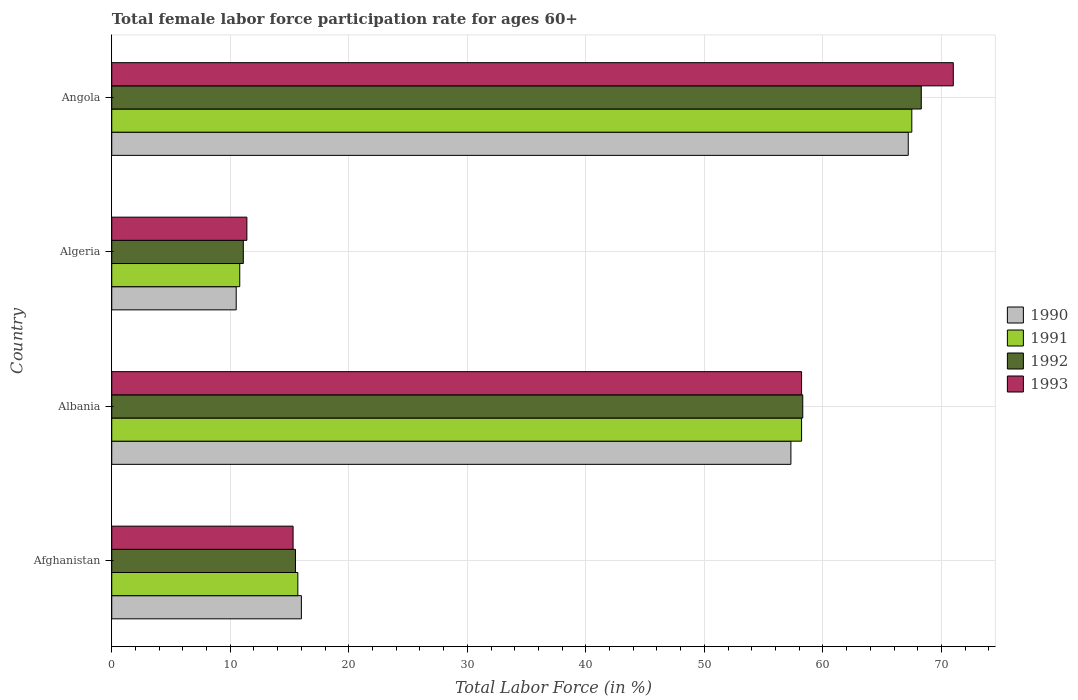How many groups of bars are there?
Provide a short and direct response. 4. Are the number of bars per tick equal to the number of legend labels?
Your answer should be compact. Yes. Are the number of bars on each tick of the Y-axis equal?
Offer a terse response. Yes. How many bars are there on the 2nd tick from the top?
Ensure brevity in your answer.  4. How many bars are there on the 2nd tick from the bottom?
Your response must be concise. 4. What is the label of the 2nd group of bars from the top?
Offer a very short reply. Algeria. What is the female labor force participation rate in 1992 in Angola?
Offer a terse response. 68.3. Across all countries, what is the maximum female labor force participation rate in 1992?
Your response must be concise. 68.3. Across all countries, what is the minimum female labor force participation rate in 1993?
Ensure brevity in your answer.  11.4. In which country was the female labor force participation rate in 1990 maximum?
Provide a succinct answer. Angola. In which country was the female labor force participation rate in 1990 minimum?
Make the answer very short. Algeria. What is the total female labor force participation rate in 1991 in the graph?
Your response must be concise. 152.2. What is the difference between the female labor force participation rate in 1990 in Algeria and that in Angola?
Your answer should be compact. -56.7. What is the difference between the female labor force participation rate in 1990 in Albania and the female labor force participation rate in 1991 in Algeria?
Make the answer very short. 46.5. What is the average female labor force participation rate in 1992 per country?
Your answer should be compact. 38.3. What is the difference between the female labor force participation rate in 1990 and female labor force participation rate in 1993 in Albania?
Keep it short and to the point. -0.9. In how many countries, is the female labor force participation rate in 1991 greater than 6 %?
Your answer should be compact. 4. What is the ratio of the female labor force participation rate in 1991 in Afghanistan to that in Algeria?
Your answer should be very brief. 1.45. Is the difference between the female labor force participation rate in 1990 in Albania and Algeria greater than the difference between the female labor force participation rate in 1993 in Albania and Algeria?
Provide a succinct answer. No. What is the difference between the highest and the second highest female labor force participation rate in 1991?
Ensure brevity in your answer.  9.3. What is the difference between the highest and the lowest female labor force participation rate in 1991?
Your answer should be compact. 56.7. In how many countries, is the female labor force participation rate in 1990 greater than the average female labor force participation rate in 1990 taken over all countries?
Give a very brief answer. 2. Is it the case that in every country, the sum of the female labor force participation rate in 1990 and female labor force participation rate in 1991 is greater than the sum of female labor force participation rate in 1992 and female labor force participation rate in 1993?
Provide a short and direct response. No. What does the 2nd bar from the top in Afghanistan represents?
Offer a terse response. 1992. What is the difference between two consecutive major ticks on the X-axis?
Keep it short and to the point. 10. Are the values on the major ticks of X-axis written in scientific E-notation?
Offer a terse response. No. Does the graph contain grids?
Make the answer very short. Yes. How are the legend labels stacked?
Give a very brief answer. Vertical. What is the title of the graph?
Your answer should be compact. Total female labor force participation rate for ages 60+. What is the label or title of the Y-axis?
Ensure brevity in your answer.  Country. What is the Total Labor Force (in %) in 1990 in Afghanistan?
Give a very brief answer. 16. What is the Total Labor Force (in %) in 1991 in Afghanistan?
Provide a short and direct response. 15.7. What is the Total Labor Force (in %) of 1993 in Afghanistan?
Give a very brief answer. 15.3. What is the Total Labor Force (in %) of 1990 in Albania?
Keep it short and to the point. 57.3. What is the Total Labor Force (in %) of 1991 in Albania?
Offer a terse response. 58.2. What is the Total Labor Force (in %) in 1992 in Albania?
Provide a succinct answer. 58.3. What is the Total Labor Force (in %) in 1993 in Albania?
Your response must be concise. 58.2. What is the Total Labor Force (in %) in 1991 in Algeria?
Ensure brevity in your answer.  10.8. What is the Total Labor Force (in %) of 1992 in Algeria?
Provide a succinct answer. 11.1. What is the Total Labor Force (in %) in 1993 in Algeria?
Your answer should be compact. 11.4. What is the Total Labor Force (in %) in 1990 in Angola?
Your answer should be very brief. 67.2. What is the Total Labor Force (in %) of 1991 in Angola?
Your response must be concise. 67.5. What is the Total Labor Force (in %) of 1992 in Angola?
Ensure brevity in your answer.  68.3. What is the Total Labor Force (in %) in 1993 in Angola?
Your answer should be very brief. 71. Across all countries, what is the maximum Total Labor Force (in %) in 1990?
Keep it short and to the point. 67.2. Across all countries, what is the maximum Total Labor Force (in %) in 1991?
Your response must be concise. 67.5. Across all countries, what is the maximum Total Labor Force (in %) in 1992?
Your answer should be compact. 68.3. Across all countries, what is the maximum Total Labor Force (in %) of 1993?
Offer a very short reply. 71. Across all countries, what is the minimum Total Labor Force (in %) in 1991?
Your answer should be compact. 10.8. Across all countries, what is the minimum Total Labor Force (in %) in 1992?
Your answer should be very brief. 11.1. Across all countries, what is the minimum Total Labor Force (in %) in 1993?
Provide a short and direct response. 11.4. What is the total Total Labor Force (in %) of 1990 in the graph?
Your response must be concise. 151. What is the total Total Labor Force (in %) of 1991 in the graph?
Offer a terse response. 152.2. What is the total Total Labor Force (in %) in 1992 in the graph?
Your answer should be compact. 153.2. What is the total Total Labor Force (in %) of 1993 in the graph?
Make the answer very short. 155.9. What is the difference between the Total Labor Force (in %) of 1990 in Afghanistan and that in Albania?
Ensure brevity in your answer.  -41.3. What is the difference between the Total Labor Force (in %) of 1991 in Afghanistan and that in Albania?
Keep it short and to the point. -42.5. What is the difference between the Total Labor Force (in %) of 1992 in Afghanistan and that in Albania?
Your response must be concise. -42.8. What is the difference between the Total Labor Force (in %) in 1993 in Afghanistan and that in Albania?
Your answer should be very brief. -42.9. What is the difference between the Total Labor Force (in %) of 1990 in Afghanistan and that in Algeria?
Offer a terse response. 5.5. What is the difference between the Total Labor Force (in %) in 1990 in Afghanistan and that in Angola?
Your answer should be compact. -51.2. What is the difference between the Total Labor Force (in %) of 1991 in Afghanistan and that in Angola?
Provide a short and direct response. -51.8. What is the difference between the Total Labor Force (in %) in 1992 in Afghanistan and that in Angola?
Offer a terse response. -52.8. What is the difference between the Total Labor Force (in %) of 1993 in Afghanistan and that in Angola?
Your answer should be very brief. -55.7. What is the difference between the Total Labor Force (in %) of 1990 in Albania and that in Algeria?
Offer a terse response. 46.8. What is the difference between the Total Labor Force (in %) in 1991 in Albania and that in Algeria?
Provide a short and direct response. 47.4. What is the difference between the Total Labor Force (in %) in 1992 in Albania and that in Algeria?
Your answer should be compact. 47.2. What is the difference between the Total Labor Force (in %) of 1993 in Albania and that in Algeria?
Your answer should be very brief. 46.8. What is the difference between the Total Labor Force (in %) in 1991 in Albania and that in Angola?
Keep it short and to the point. -9.3. What is the difference between the Total Labor Force (in %) in 1992 in Albania and that in Angola?
Keep it short and to the point. -10. What is the difference between the Total Labor Force (in %) in 1993 in Albania and that in Angola?
Keep it short and to the point. -12.8. What is the difference between the Total Labor Force (in %) in 1990 in Algeria and that in Angola?
Offer a terse response. -56.7. What is the difference between the Total Labor Force (in %) in 1991 in Algeria and that in Angola?
Keep it short and to the point. -56.7. What is the difference between the Total Labor Force (in %) of 1992 in Algeria and that in Angola?
Provide a succinct answer. -57.2. What is the difference between the Total Labor Force (in %) in 1993 in Algeria and that in Angola?
Give a very brief answer. -59.6. What is the difference between the Total Labor Force (in %) of 1990 in Afghanistan and the Total Labor Force (in %) of 1991 in Albania?
Your answer should be compact. -42.2. What is the difference between the Total Labor Force (in %) in 1990 in Afghanistan and the Total Labor Force (in %) in 1992 in Albania?
Your answer should be very brief. -42.3. What is the difference between the Total Labor Force (in %) of 1990 in Afghanistan and the Total Labor Force (in %) of 1993 in Albania?
Your answer should be compact. -42.2. What is the difference between the Total Labor Force (in %) in 1991 in Afghanistan and the Total Labor Force (in %) in 1992 in Albania?
Offer a terse response. -42.6. What is the difference between the Total Labor Force (in %) in 1991 in Afghanistan and the Total Labor Force (in %) in 1993 in Albania?
Give a very brief answer. -42.5. What is the difference between the Total Labor Force (in %) in 1992 in Afghanistan and the Total Labor Force (in %) in 1993 in Albania?
Provide a short and direct response. -42.7. What is the difference between the Total Labor Force (in %) of 1991 in Afghanistan and the Total Labor Force (in %) of 1992 in Algeria?
Provide a short and direct response. 4.6. What is the difference between the Total Labor Force (in %) in 1990 in Afghanistan and the Total Labor Force (in %) in 1991 in Angola?
Your response must be concise. -51.5. What is the difference between the Total Labor Force (in %) of 1990 in Afghanistan and the Total Labor Force (in %) of 1992 in Angola?
Your answer should be compact. -52.3. What is the difference between the Total Labor Force (in %) in 1990 in Afghanistan and the Total Labor Force (in %) in 1993 in Angola?
Provide a short and direct response. -55. What is the difference between the Total Labor Force (in %) of 1991 in Afghanistan and the Total Labor Force (in %) of 1992 in Angola?
Your response must be concise. -52.6. What is the difference between the Total Labor Force (in %) of 1991 in Afghanistan and the Total Labor Force (in %) of 1993 in Angola?
Give a very brief answer. -55.3. What is the difference between the Total Labor Force (in %) in 1992 in Afghanistan and the Total Labor Force (in %) in 1993 in Angola?
Your answer should be compact. -55.5. What is the difference between the Total Labor Force (in %) of 1990 in Albania and the Total Labor Force (in %) of 1991 in Algeria?
Provide a succinct answer. 46.5. What is the difference between the Total Labor Force (in %) in 1990 in Albania and the Total Labor Force (in %) in 1992 in Algeria?
Keep it short and to the point. 46.2. What is the difference between the Total Labor Force (in %) in 1990 in Albania and the Total Labor Force (in %) in 1993 in Algeria?
Give a very brief answer. 45.9. What is the difference between the Total Labor Force (in %) of 1991 in Albania and the Total Labor Force (in %) of 1992 in Algeria?
Ensure brevity in your answer.  47.1. What is the difference between the Total Labor Force (in %) of 1991 in Albania and the Total Labor Force (in %) of 1993 in Algeria?
Provide a succinct answer. 46.8. What is the difference between the Total Labor Force (in %) of 1992 in Albania and the Total Labor Force (in %) of 1993 in Algeria?
Provide a short and direct response. 46.9. What is the difference between the Total Labor Force (in %) of 1990 in Albania and the Total Labor Force (in %) of 1991 in Angola?
Your answer should be compact. -10.2. What is the difference between the Total Labor Force (in %) of 1990 in Albania and the Total Labor Force (in %) of 1993 in Angola?
Make the answer very short. -13.7. What is the difference between the Total Labor Force (in %) of 1991 in Albania and the Total Labor Force (in %) of 1992 in Angola?
Provide a succinct answer. -10.1. What is the difference between the Total Labor Force (in %) of 1991 in Albania and the Total Labor Force (in %) of 1993 in Angola?
Provide a short and direct response. -12.8. What is the difference between the Total Labor Force (in %) of 1990 in Algeria and the Total Labor Force (in %) of 1991 in Angola?
Ensure brevity in your answer.  -57. What is the difference between the Total Labor Force (in %) in 1990 in Algeria and the Total Labor Force (in %) in 1992 in Angola?
Offer a very short reply. -57.8. What is the difference between the Total Labor Force (in %) in 1990 in Algeria and the Total Labor Force (in %) in 1993 in Angola?
Provide a succinct answer. -60.5. What is the difference between the Total Labor Force (in %) of 1991 in Algeria and the Total Labor Force (in %) of 1992 in Angola?
Your answer should be compact. -57.5. What is the difference between the Total Labor Force (in %) of 1991 in Algeria and the Total Labor Force (in %) of 1993 in Angola?
Ensure brevity in your answer.  -60.2. What is the difference between the Total Labor Force (in %) of 1992 in Algeria and the Total Labor Force (in %) of 1993 in Angola?
Ensure brevity in your answer.  -59.9. What is the average Total Labor Force (in %) in 1990 per country?
Ensure brevity in your answer.  37.75. What is the average Total Labor Force (in %) of 1991 per country?
Your answer should be compact. 38.05. What is the average Total Labor Force (in %) of 1992 per country?
Your response must be concise. 38.3. What is the average Total Labor Force (in %) of 1993 per country?
Your answer should be very brief. 38.98. What is the difference between the Total Labor Force (in %) in 1990 and Total Labor Force (in %) in 1991 in Afghanistan?
Offer a very short reply. 0.3. What is the difference between the Total Labor Force (in %) of 1990 and Total Labor Force (in %) of 1992 in Afghanistan?
Make the answer very short. 0.5. What is the difference between the Total Labor Force (in %) in 1990 and Total Labor Force (in %) in 1993 in Afghanistan?
Your answer should be very brief. 0.7. What is the difference between the Total Labor Force (in %) of 1991 and Total Labor Force (in %) of 1992 in Afghanistan?
Give a very brief answer. 0.2. What is the difference between the Total Labor Force (in %) of 1991 and Total Labor Force (in %) of 1993 in Afghanistan?
Your answer should be compact. 0.4. What is the difference between the Total Labor Force (in %) in 1990 and Total Labor Force (in %) in 1993 in Albania?
Provide a short and direct response. -0.9. What is the difference between the Total Labor Force (in %) in 1991 and Total Labor Force (in %) in 1992 in Albania?
Offer a terse response. -0.1. What is the difference between the Total Labor Force (in %) of 1991 and Total Labor Force (in %) of 1993 in Albania?
Ensure brevity in your answer.  0. What is the difference between the Total Labor Force (in %) of 1992 and Total Labor Force (in %) of 1993 in Albania?
Give a very brief answer. 0.1. What is the difference between the Total Labor Force (in %) of 1990 and Total Labor Force (in %) of 1991 in Algeria?
Keep it short and to the point. -0.3. What is the difference between the Total Labor Force (in %) of 1990 and Total Labor Force (in %) of 1992 in Algeria?
Your answer should be very brief. -0.6. What is the difference between the Total Labor Force (in %) of 1990 and Total Labor Force (in %) of 1993 in Algeria?
Give a very brief answer. -0.9. What is the difference between the Total Labor Force (in %) in 1991 and Total Labor Force (in %) in 1992 in Algeria?
Provide a short and direct response. -0.3. What is the difference between the Total Labor Force (in %) of 1992 and Total Labor Force (in %) of 1993 in Algeria?
Your response must be concise. -0.3. What is the difference between the Total Labor Force (in %) in 1990 and Total Labor Force (in %) in 1992 in Angola?
Provide a succinct answer. -1.1. What is the difference between the Total Labor Force (in %) of 1991 and Total Labor Force (in %) of 1993 in Angola?
Make the answer very short. -3.5. What is the difference between the Total Labor Force (in %) of 1992 and Total Labor Force (in %) of 1993 in Angola?
Offer a very short reply. -2.7. What is the ratio of the Total Labor Force (in %) in 1990 in Afghanistan to that in Albania?
Provide a succinct answer. 0.28. What is the ratio of the Total Labor Force (in %) in 1991 in Afghanistan to that in Albania?
Keep it short and to the point. 0.27. What is the ratio of the Total Labor Force (in %) of 1992 in Afghanistan to that in Albania?
Ensure brevity in your answer.  0.27. What is the ratio of the Total Labor Force (in %) of 1993 in Afghanistan to that in Albania?
Provide a succinct answer. 0.26. What is the ratio of the Total Labor Force (in %) of 1990 in Afghanistan to that in Algeria?
Provide a short and direct response. 1.52. What is the ratio of the Total Labor Force (in %) in 1991 in Afghanistan to that in Algeria?
Your answer should be very brief. 1.45. What is the ratio of the Total Labor Force (in %) of 1992 in Afghanistan to that in Algeria?
Your answer should be compact. 1.4. What is the ratio of the Total Labor Force (in %) in 1993 in Afghanistan to that in Algeria?
Provide a succinct answer. 1.34. What is the ratio of the Total Labor Force (in %) in 1990 in Afghanistan to that in Angola?
Provide a short and direct response. 0.24. What is the ratio of the Total Labor Force (in %) in 1991 in Afghanistan to that in Angola?
Your answer should be very brief. 0.23. What is the ratio of the Total Labor Force (in %) of 1992 in Afghanistan to that in Angola?
Give a very brief answer. 0.23. What is the ratio of the Total Labor Force (in %) in 1993 in Afghanistan to that in Angola?
Provide a short and direct response. 0.22. What is the ratio of the Total Labor Force (in %) of 1990 in Albania to that in Algeria?
Your answer should be very brief. 5.46. What is the ratio of the Total Labor Force (in %) of 1991 in Albania to that in Algeria?
Ensure brevity in your answer.  5.39. What is the ratio of the Total Labor Force (in %) of 1992 in Albania to that in Algeria?
Offer a terse response. 5.25. What is the ratio of the Total Labor Force (in %) in 1993 in Albania to that in Algeria?
Ensure brevity in your answer.  5.11. What is the ratio of the Total Labor Force (in %) in 1990 in Albania to that in Angola?
Your response must be concise. 0.85. What is the ratio of the Total Labor Force (in %) in 1991 in Albania to that in Angola?
Provide a succinct answer. 0.86. What is the ratio of the Total Labor Force (in %) of 1992 in Albania to that in Angola?
Offer a very short reply. 0.85. What is the ratio of the Total Labor Force (in %) of 1993 in Albania to that in Angola?
Your response must be concise. 0.82. What is the ratio of the Total Labor Force (in %) of 1990 in Algeria to that in Angola?
Keep it short and to the point. 0.16. What is the ratio of the Total Labor Force (in %) in 1991 in Algeria to that in Angola?
Offer a terse response. 0.16. What is the ratio of the Total Labor Force (in %) in 1992 in Algeria to that in Angola?
Provide a short and direct response. 0.16. What is the ratio of the Total Labor Force (in %) in 1993 in Algeria to that in Angola?
Make the answer very short. 0.16. What is the difference between the highest and the second highest Total Labor Force (in %) in 1990?
Keep it short and to the point. 9.9. What is the difference between the highest and the second highest Total Labor Force (in %) of 1991?
Offer a very short reply. 9.3. What is the difference between the highest and the second highest Total Labor Force (in %) of 1992?
Offer a very short reply. 10. What is the difference between the highest and the second highest Total Labor Force (in %) in 1993?
Ensure brevity in your answer.  12.8. What is the difference between the highest and the lowest Total Labor Force (in %) of 1990?
Ensure brevity in your answer.  56.7. What is the difference between the highest and the lowest Total Labor Force (in %) in 1991?
Keep it short and to the point. 56.7. What is the difference between the highest and the lowest Total Labor Force (in %) in 1992?
Make the answer very short. 57.2. What is the difference between the highest and the lowest Total Labor Force (in %) of 1993?
Offer a very short reply. 59.6. 